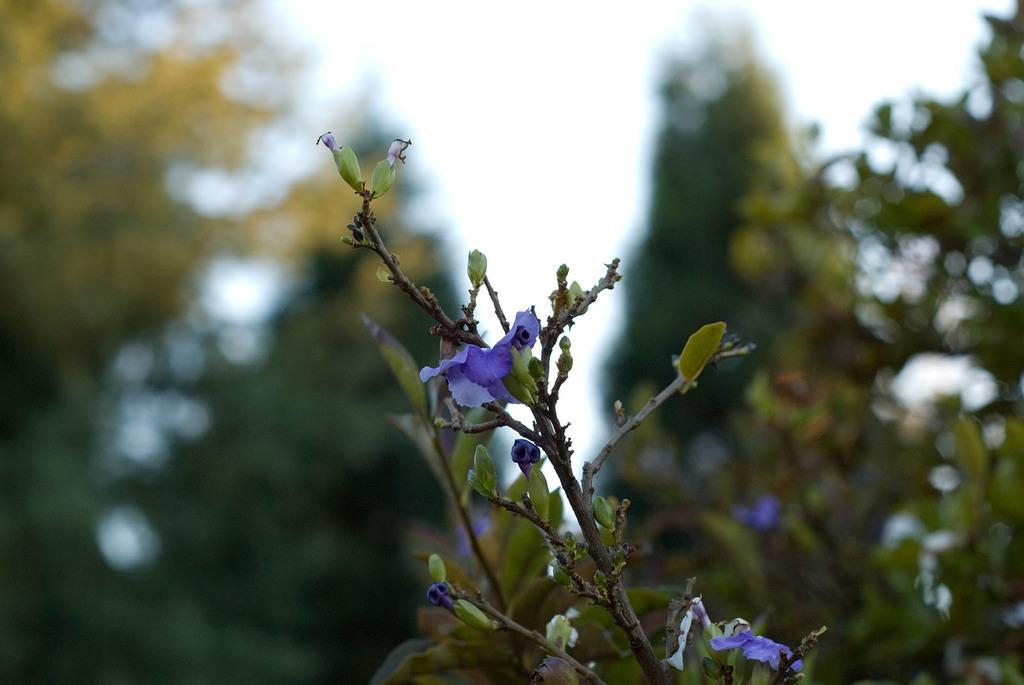In one or two sentences, can you explain what this image depicts? In this image in the foreground there is a plant and flowers, and in the background there are trees and sky. 